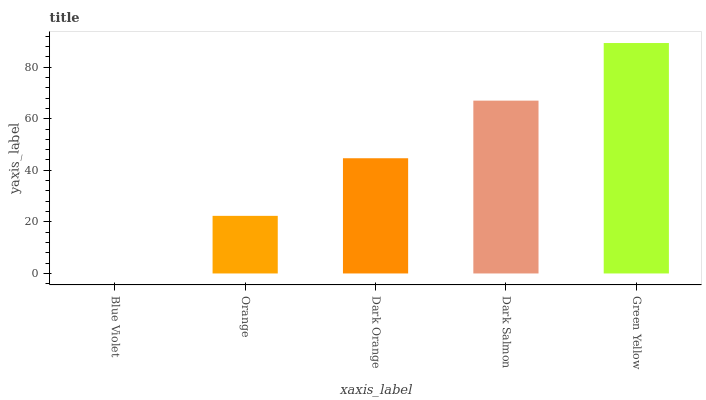Is Blue Violet the minimum?
Answer yes or no. Yes. Is Green Yellow the maximum?
Answer yes or no. Yes. Is Orange the minimum?
Answer yes or no. No. Is Orange the maximum?
Answer yes or no. No. Is Orange greater than Blue Violet?
Answer yes or no. Yes. Is Blue Violet less than Orange?
Answer yes or no. Yes. Is Blue Violet greater than Orange?
Answer yes or no. No. Is Orange less than Blue Violet?
Answer yes or no. No. Is Dark Orange the high median?
Answer yes or no. Yes. Is Dark Orange the low median?
Answer yes or no. Yes. Is Orange the high median?
Answer yes or no. No. Is Orange the low median?
Answer yes or no. No. 